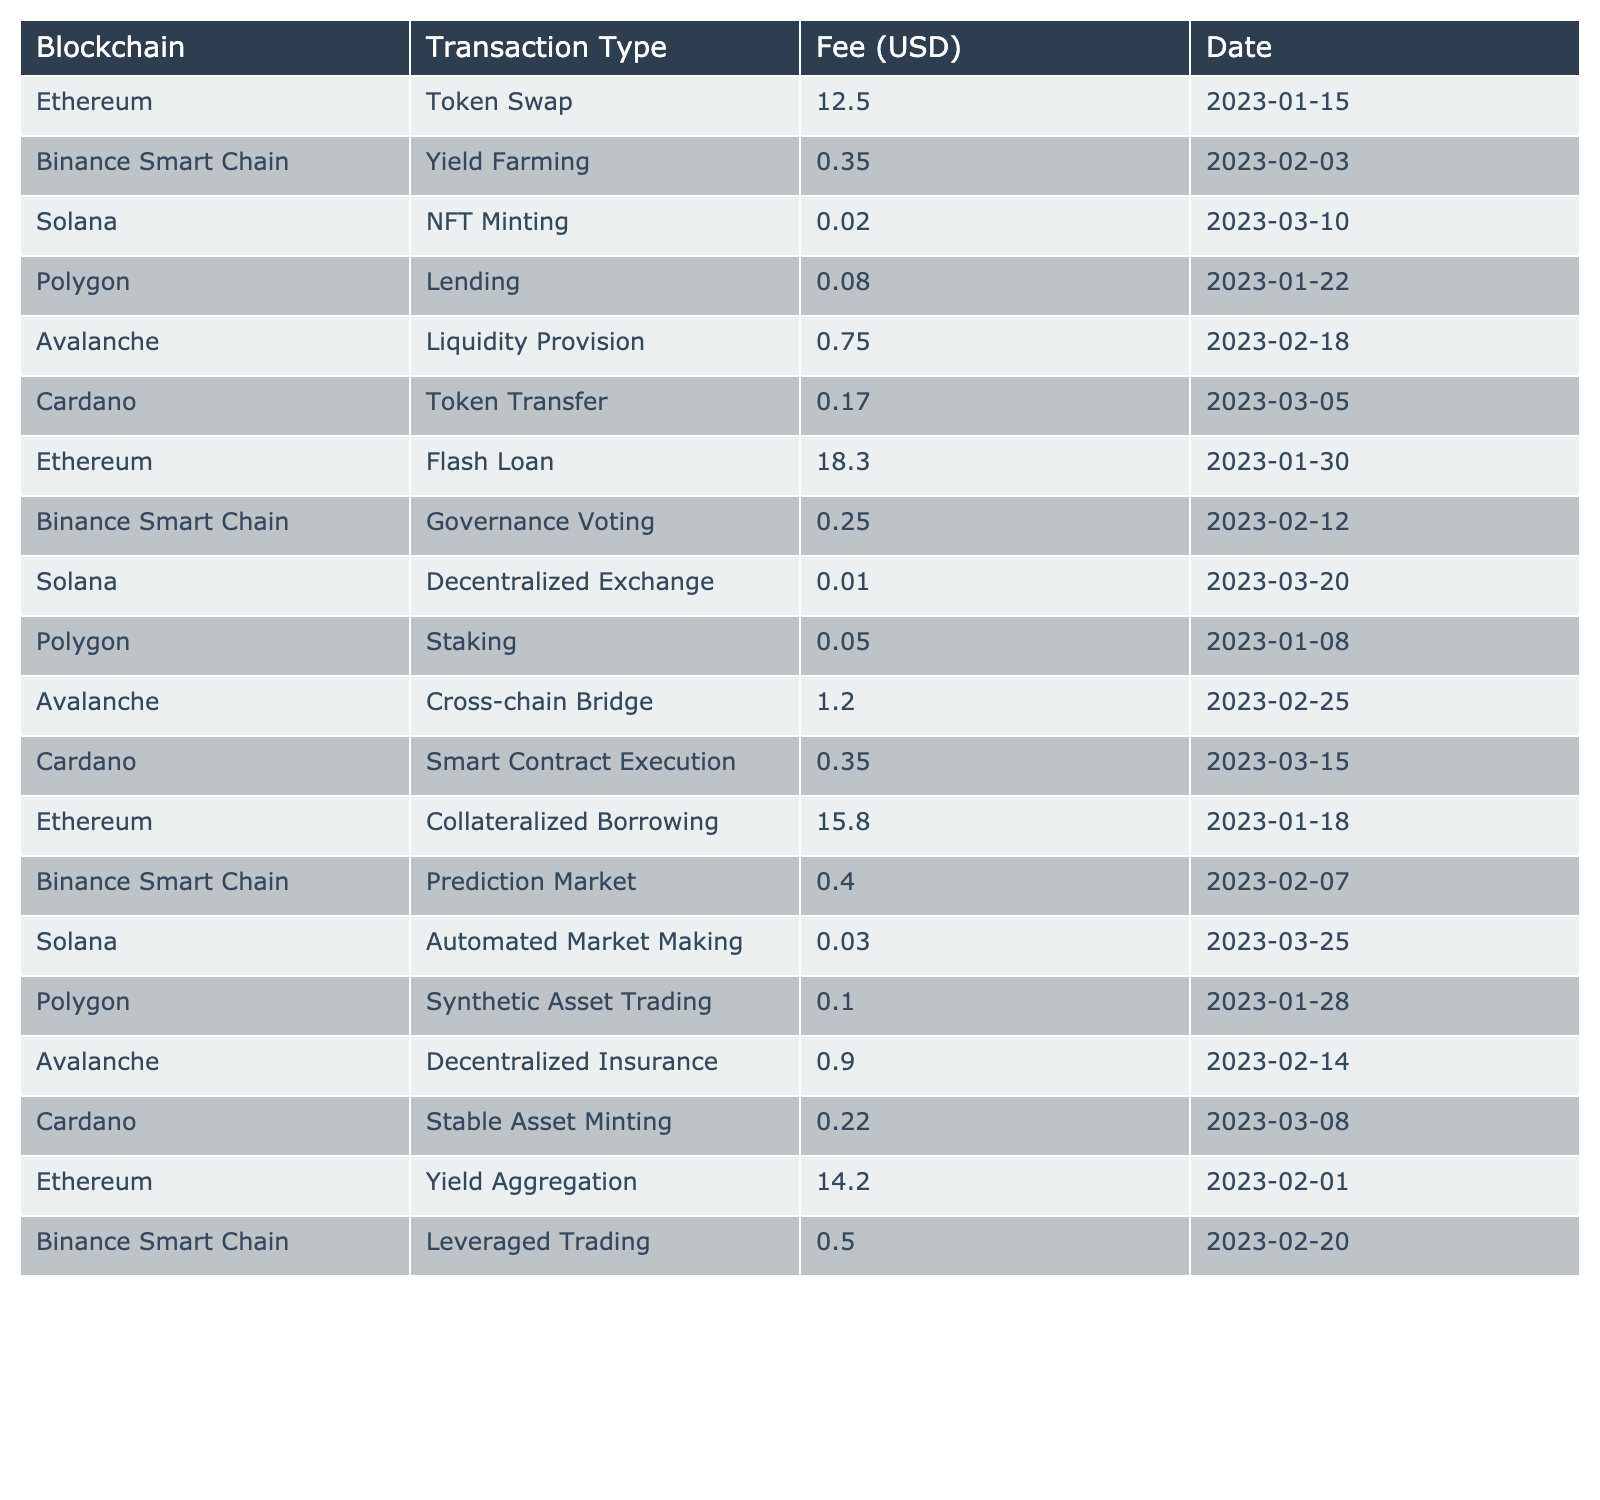What is the highest transaction fee listed in the table? Scanning the "Fee (USD)" column, the highest value is found, which is 18.30 corresponding to Ethereum's Flash Loan on January 30, 2023.
Answer: 18.30 Which blockchain had the lowest transaction fee for any operation? Looking through the table, the lowest fee of 0.01 is associated with Solana's Decentralized Exchange on March 20, 2023.
Answer: 0.01 What is the average transaction fee for Ethereum operations? The Ethereum fees are 12.50, 18.30, 15.80, and 14.20. Summing these gives 60.80 and dividing by 4 results in an average of 15.20.
Answer: 15.20 Is there any transaction on Cardano that has a fee greater than 0.20? Referring to the Cardano rows, Token Transfer has 0.17, Smart Contract Execution has 0.35, and Stable Asset Minting has 0.22; thus, at least one value (0.35) is indeed greater than 0.20.
Answer: Yes How much is the total fee for all operations on Binance Smart Chain? The fees for Binance Smart Chain are 0.35 (Yield Farming), 0.25 (Governance Voting), 0.40 (Prediction Market), and 0.50 (Leveraged Trading). Summing these gives 1.50 in total.
Answer: 1.50 Which blockchain had the most entries in the table? By counting the rows for each blockchain, Ethereum has 4 entries, Binance Smart Chain has 4, Solana has 4, Polygon has 4, Avalanche has 4, and Cardano has 4 as well. Each blockchain has an equal number of entries, so there is no single blockchain with the most entries.
Answer: None What is the difference in transaction fees between Solana's NFT Minting and Automated Market Making? The fee for NFT Minting is 0.02 and for Automated Market Making it is 0.03. The difference is calculated as 0.03 - 0.02 = 0.01.
Answer: 0.01 If we combine all fees from Polygon operations, what is the total? The polygon fees include 0.08 (Lending), 0.05 (Staking), and 0.10 (Synthetic Asset Trading). Adding these gives 0.08 + 0.05 + 0.10 = 0.23.
Answer: 0.23 Which transaction type has the second highest fee in the table? The highest fee is 18.30 (Flash Loan), followed by 15.80 (Collateralized Borrowing from Ethereum). Therefore, the second highest fee is 15.80.
Answer: 15.80 How many different transaction types are listed for Avalanche? Avalanche has 2 transaction types listed: Liquidity Provision and Cross-chain Bridge. This indicates that Avalanche features a limited number of specific transactions compared to others.
Answer: 2 